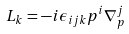<formula> <loc_0><loc_0><loc_500><loc_500>L _ { k } = - i \epsilon _ { i j k } p ^ { i } \nabla _ { p } ^ { j }</formula> 